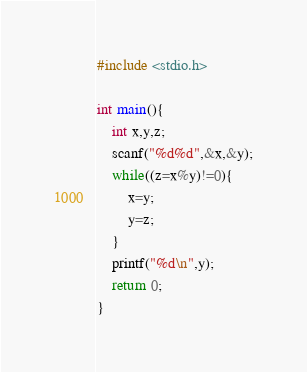<code> <loc_0><loc_0><loc_500><loc_500><_C_>#include <stdio.h>

int main(){
    int x,y,z;
    scanf("%d%d",&x,&y);
    while((z=x%y)!=0){
        x=y;
        y=z;
    }
    printf("%d\n",y);
    return 0;
}

</code> 